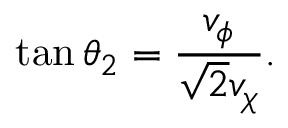Convert formula to latex. <formula><loc_0><loc_0><loc_500><loc_500>\tan \theta _ { 2 } = \frac { v _ { \phi } } { \sqrt { 2 } v _ { \chi } } .</formula> 